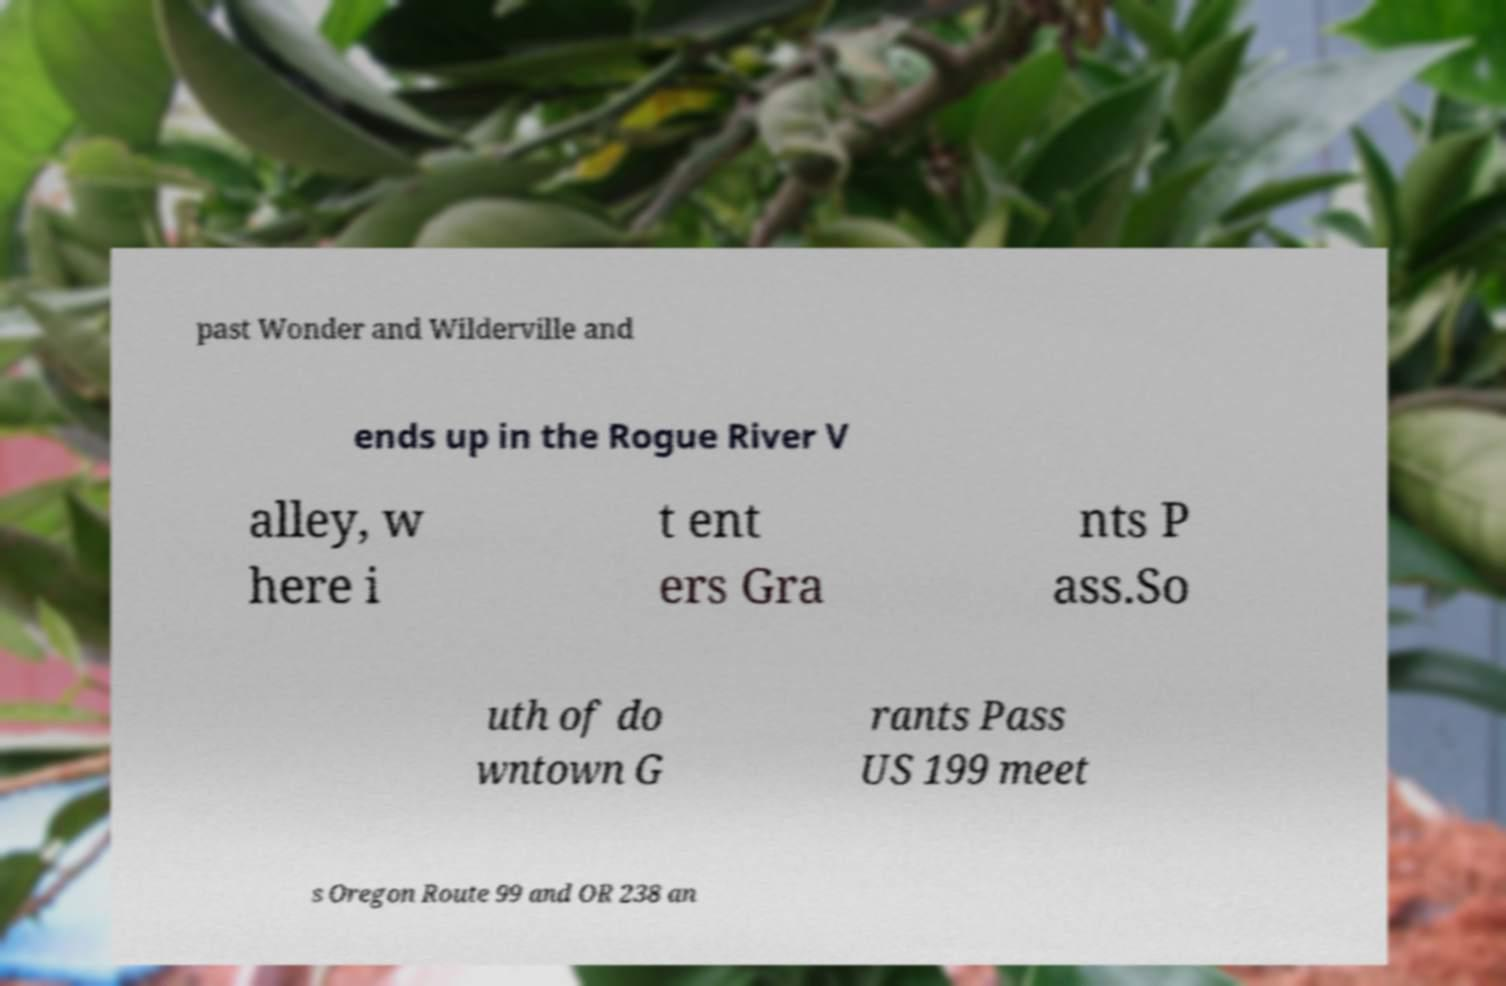There's text embedded in this image that I need extracted. Can you transcribe it verbatim? past Wonder and Wilderville and ends up in the Rogue River V alley, w here i t ent ers Gra nts P ass.So uth of do wntown G rants Pass US 199 meet s Oregon Route 99 and OR 238 an 